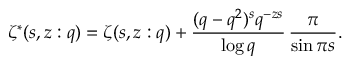Convert formula to latex. <formula><loc_0><loc_0><loc_500><loc_500>\zeta ^ { * } ( s , z \colon q ) = \zeta ( s , z \colon q ) + \frac { ( q - q ^ { 2 } ) ^ { s } q ^ { - z s } } { \log q } \, \frac { \pi } { \sin \pi s } .</formula> 